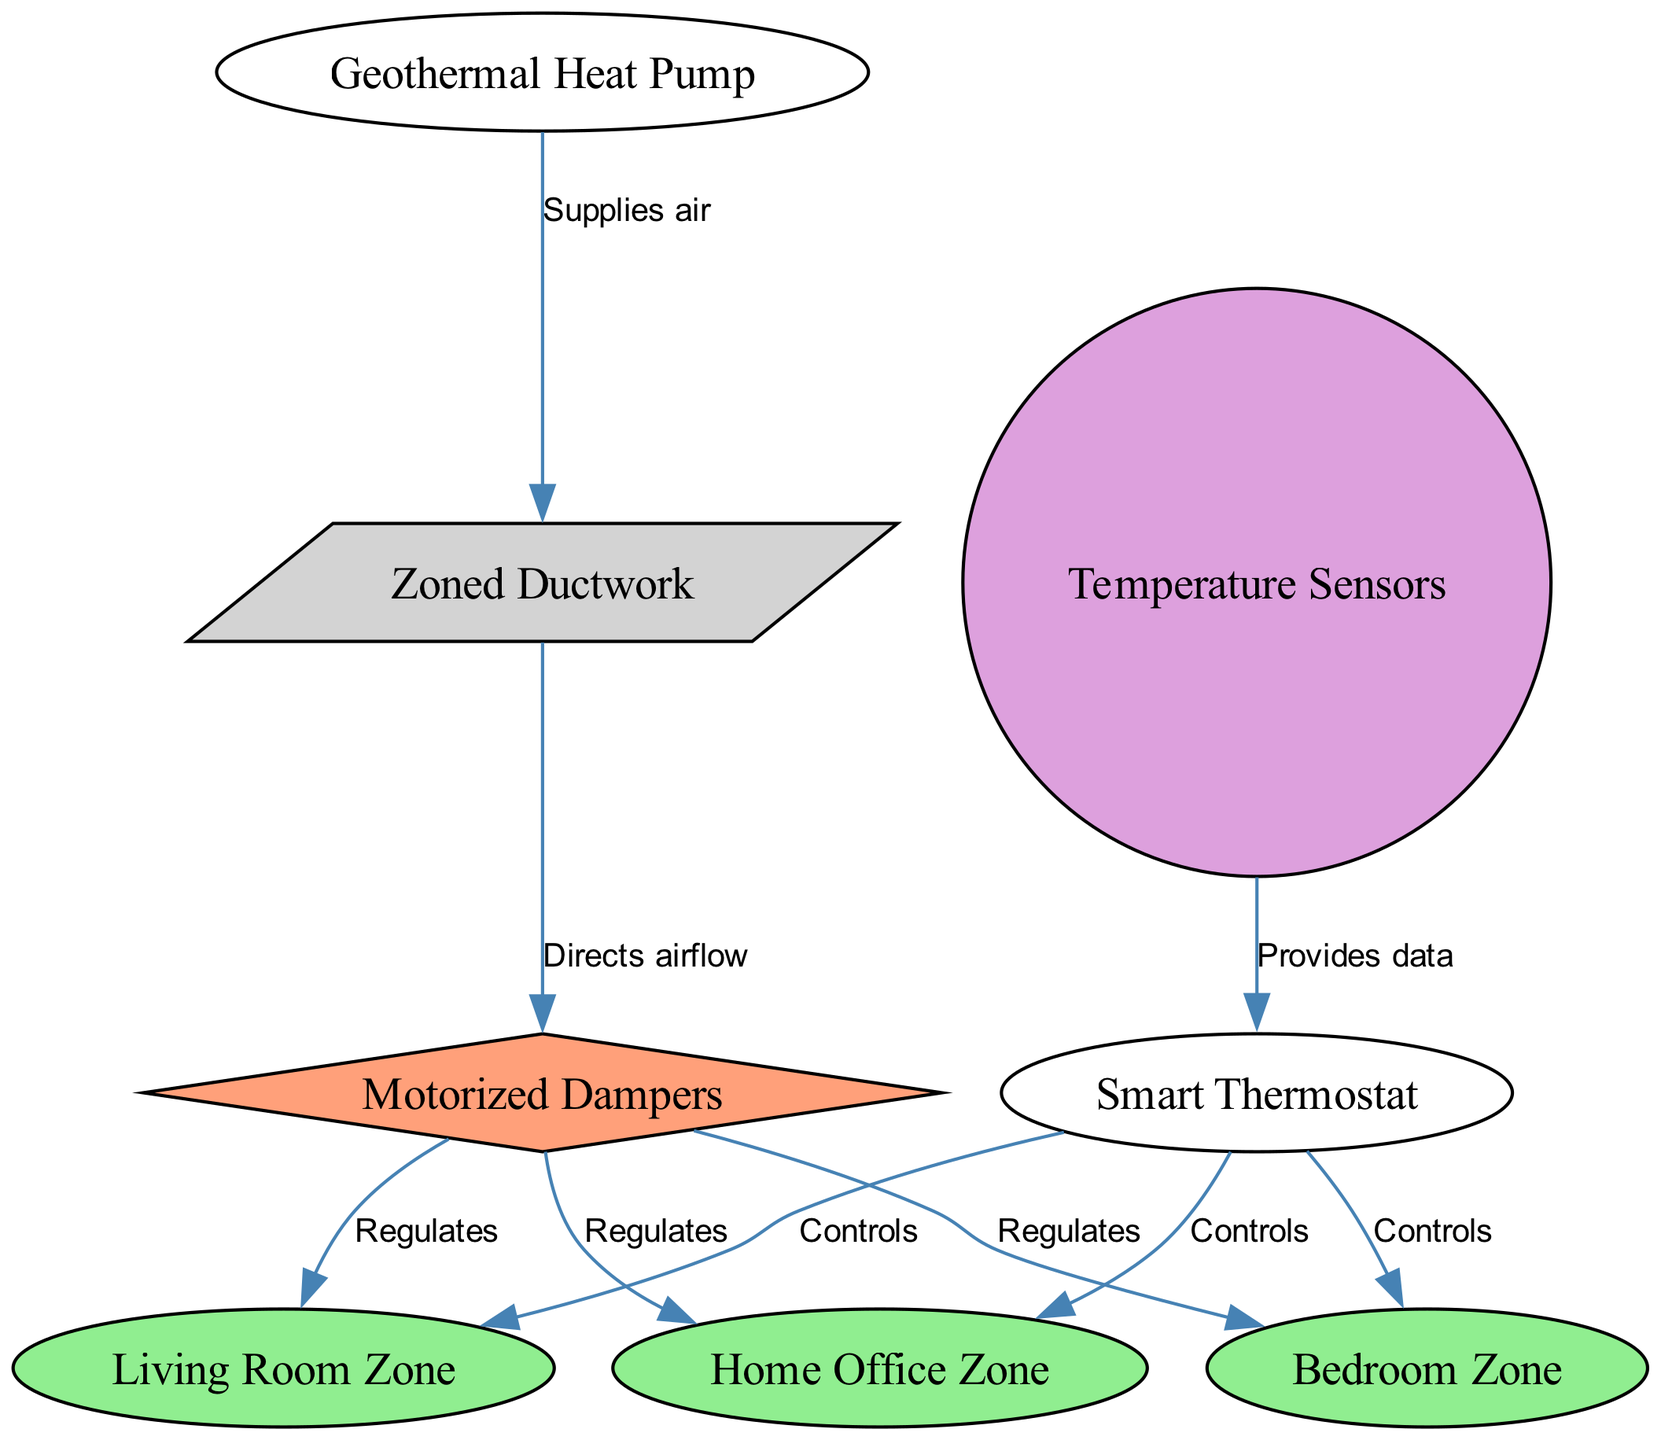What is the main component controlling all zones? The "Smart Thermostat" is depicted as the central node connected to all zones, indicating it controls temperature settings for the Living Room, Bedroom, and Home Office zones.
Answer: Smart Thermostat How many zones are represented in the diagram? There are three zones shown: "Living Room Zone," "Bedroom Zone," and "Home Office Zone." Counting these zones gives a total of three.
Answer: 3 Which component supplies air to the ductwork? The "Geothermal Heat Pump" is directly connected to the "Zoned Ductwork" node, indicating that it is the component that supplies air to the duct system.
Answer: Geothermal Heat Pump What do the motorized dampers regulate? The motorized dampers are connected to all three zones, meaning they regulate airflow into the Living Room Zone, Bedroom Zone, and Home Office Zone, depending on demand.
Answer: Airflow to zones How do temperature sensors interact with the smart thermostat? The "Temperature Sensors" node is directed to the "Smart Thermostat," indicating that these sensors provide temperature data to the thermostat for better control of the HVAC system.
Answer: Provides data What is the role of the ductwork in this system? The "Zoned Ductwork" is shown to have a connection to the "Geothermal Heat Pump" and "Motorized Dampers," indicating it directs and distributes the air supplied by the heat pump to the appropriate zones regulated by the dampers.
Answer: Directs airflow How many connections does the smart thermostat have? The "Smart Thermostat" is connected to three zones, indicating that it has three connections overall to control temperature in the Living Room, Bedroom, and Home Office zones.
Answer: 3 How many motorized dampers are depicted in the diagram? The "Motorized Dampers" regulate airflow to three zones, suggesting there are at least the same number of dampers as zones, which are three. However, they are represented by a single node in the diagram.
Answer: 1 (node, but implies more dampers) What is the relationship between the ductwork and dampers? The "Ductwork" node is labeled with "Directs airflow" to "Motorized Dampers," indicating that the ductwork is responsible for directing the air flow to the dampers that then regulate airflow into individual zones.
Answer: Directs airflow 